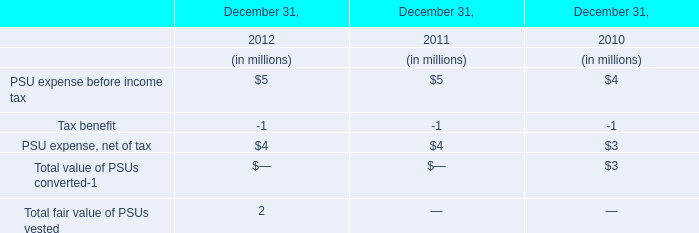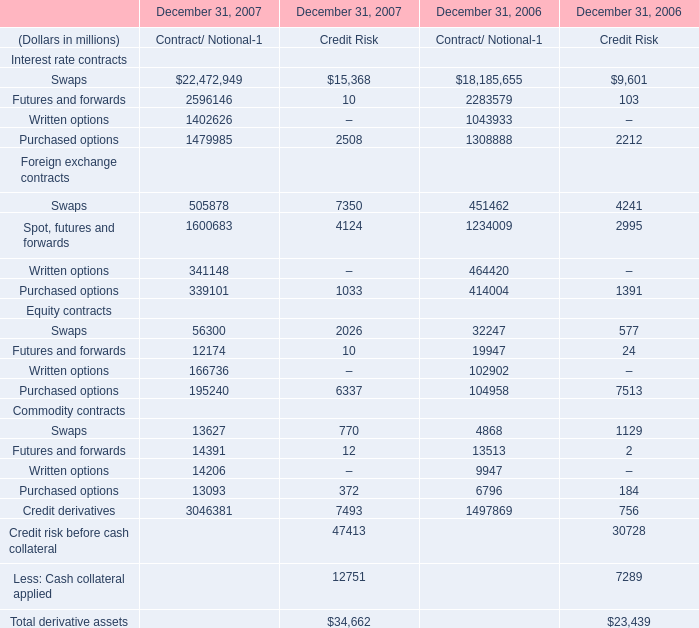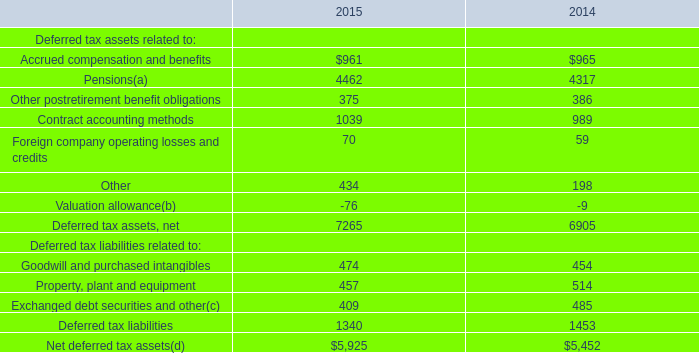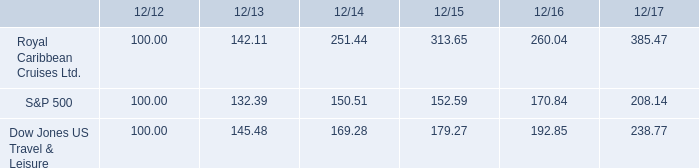If Total derivative assets develops with the same growth rate in 2007, what will it reach in 2008? (in million) 
Computations: ((((34662 - 23439) / 34662) * 34662) + 34662)
Answer: 45885.0. 